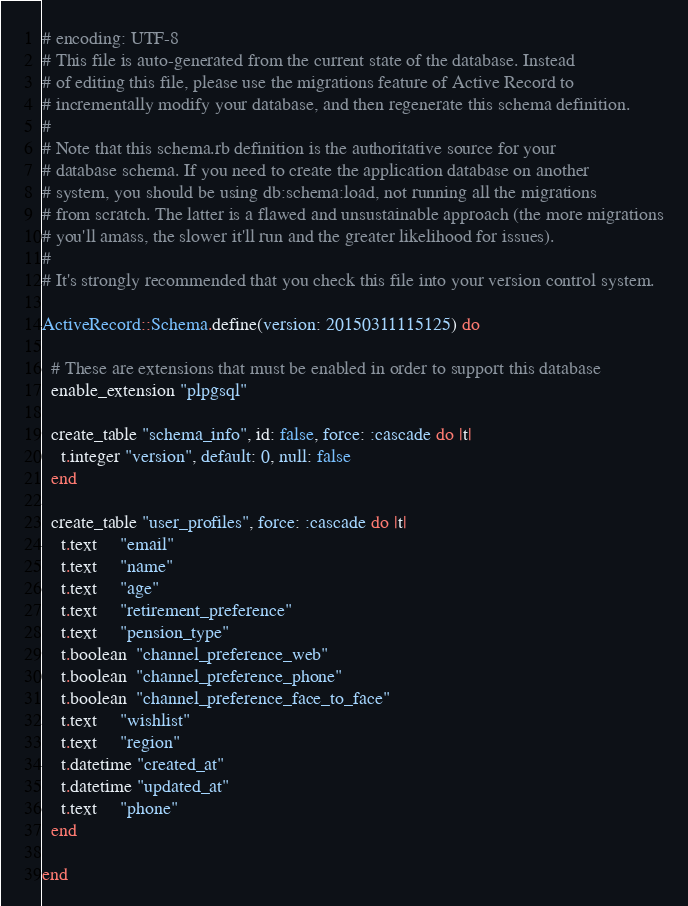<code> <loc_0><loc_0><loc_500><loc_500><_Ruby_># encoding: UTF-8
# This file is auto-generated from the current state of the database. Instead
# of editing this file, please use the migrations feature of Active Record to
# incrementally modify your database, and then regenerate this schema definition.
#
# Note that this schema.rb definition is the authoritative source for your
# database schema. If you need to create the application database on another
# system, you should be using db:schema:load, not running all the migrations
# from scratch. The latter is a flawed and unsustainable approach (the more migrations
# you'll amass, the slower it'll run and the greater likelihood for issues).
#
# It's strongly recommended that you check this file into your version control system.

ActiveRecord::Schema.define(version: 20150311115125) do

  # These are extensions that must be enabled in order to support this database
  enable_extension "plpgsql"

  create_table "schema_info", id: false, force: :cascade do |t|
    t.integer "version", default: 0, null: false
  end

  create_table "user_profiles", force: :cascade do |t|
    t.text     "email"
    t.text     "name"
    t.text     "age"
    t.text     "retirement_preference"
    t.text     "pension_type"
    t.boolean  "channel_preference_web"
    t.boolean  "channel_preference_phone"
    t.boolean  "channel_preference_face_to_face"
    t.text     "wishlist"
    t.text     "region"
    t.datetime "created_at"
    t.datetime "updated_at"
    t.text     "phone"
  end

end
</code> 